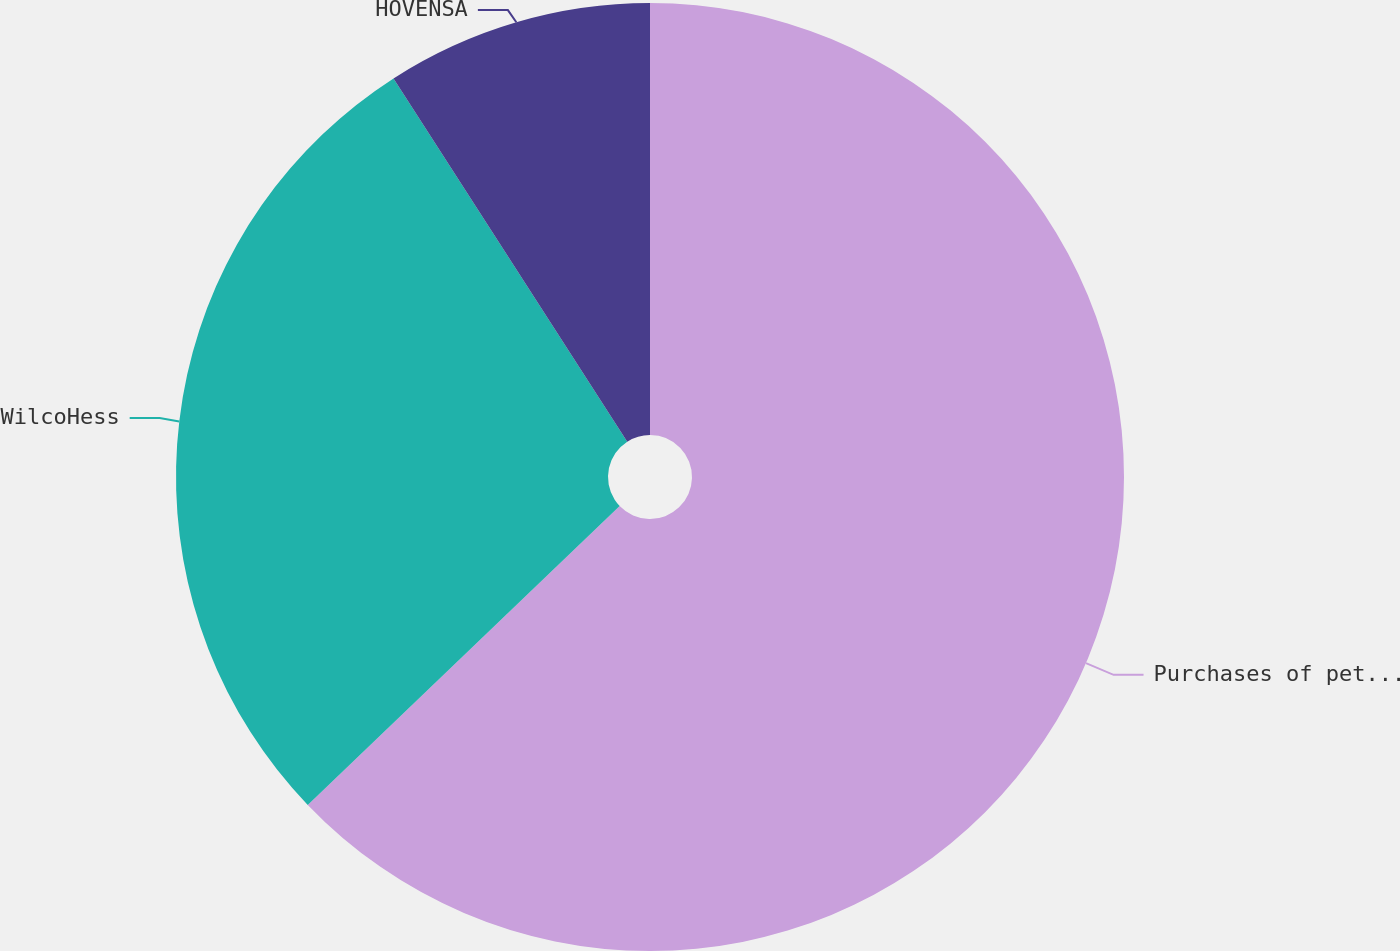Convert chart to OTSL. <chart><loc_0><loc_0><loc_500><loc_500><pie_chart><fcel>Purchases of petroleum<fcel>WilcoHess<fcel>HOVENSA<nl><fcel>62.84%<fcel>28.06%<fcel>9.1%<nl></chart> 